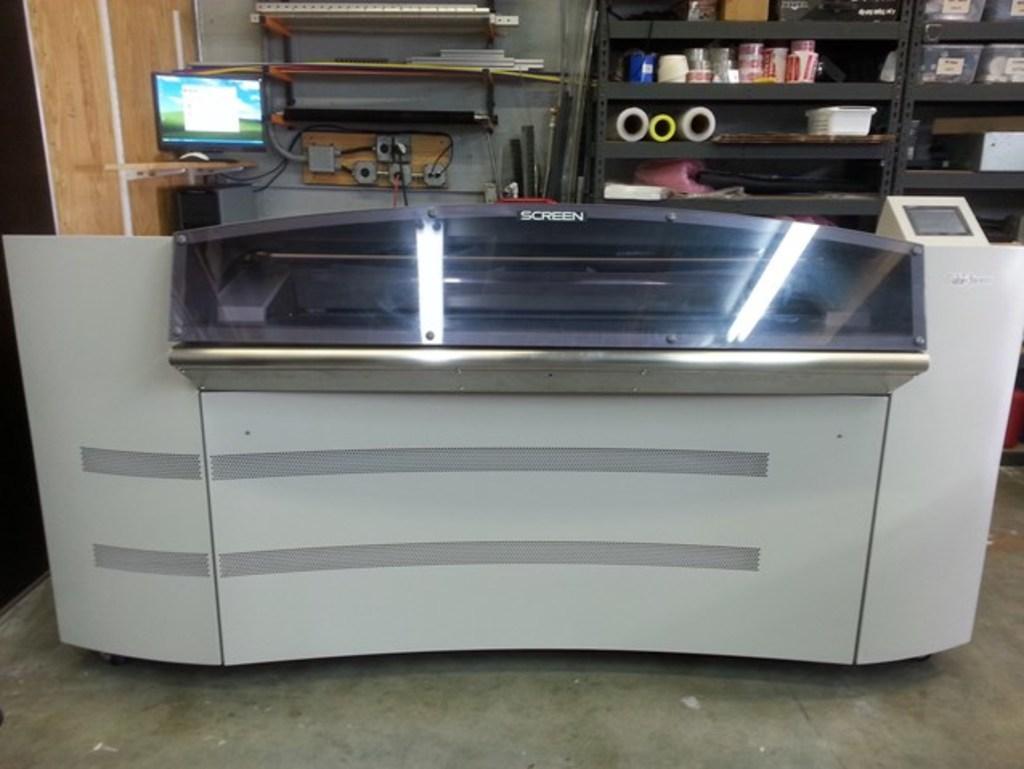Describe this image in one or two sentences. In this picture we can see a desk. There is a computer, wires and other things on the shelves. We can see sheets, boxes and other objects in the racks. 